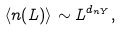<formula> <loc_0><loc_0><loc_500><loc_500>\langle n ( L ) \rangle \sim L ^ { d _ { n Y } } ,</formula> 